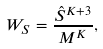Convert formula to latex. <formula><loc_0><loc_0><loc_500><loc_500>W _ { S } = \frac { \hat { S } ^ { K + 3 } } { M ^ { K } } ,</formula> 